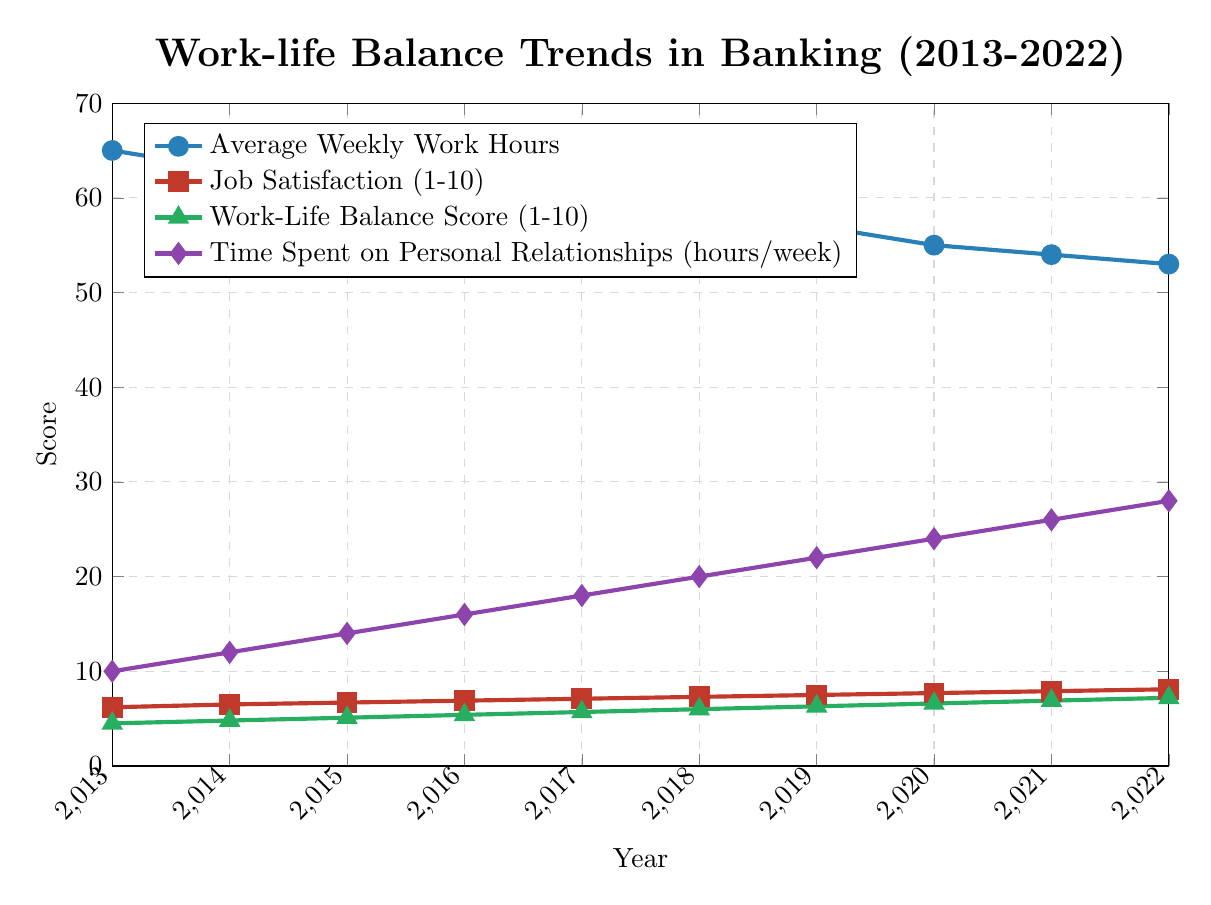How did the Average Weekly Work Hours change from 2013 to 2022? From the plot, the Average Weekly Work Hours decreased from 65 hours in 2013 to 53 hours in 2022.
Answer: Decreased from 65 to 53 hours Which year showed the highest Job Satisfaction score? Referring to the Job Satisfaction line (marked with squares), the highest value is in 2022 with a score of 8.1.
Answer: 2022 What is the trend in Time Spent on Personal Relationships from 2013 to 2022? The plot indicates a positive trend in Time Spent on Personal Relationships, increasing from 10 hours per week in 2013 to 28 hours per week in 2022.
Answer: Increasing By how much did the Work-Life Balance Score increase from 2013 to 2022? The Work-Life Balance Score increased from 4.5 in 2013 to 7.2 in 2022, resulting in an increase of 7.2 - 4.5 = 2.7.
Answer: 2.7 Which year experienced the lowest Stress Level and what was the score? The Stress Level line shows that 2022 had the lowest Stress Level with a score of 6.0.
Answer: 2022, 6.0 Compare the Job Satisfaction scores in 2015 and 2020. What is the difference? From the Job Satisfaction line, the score in 2015 was 6.7 and in 2020 it was 7.7. The difference is 7.7 - 6.7 = 1.0.
Answer: 1.0 What is the average Vacation Days Taken over the period 2013-2022? Summing the Vacation Days Taken over the 10 years: 12 + 13 + 14 + 15 + 16 + 17 + 18 + 19 + 20 + 21 = 165. The average is 165 / 10 = 16.5.
Answer: 16.5 In which year did the Time Spent on Personal Relationships exceed 20 hours per week for the first time? Referring to the plot, in 2019, the Time Spent on Personal Relationships first exceeded 20 hours per week, with a value of 22 hours.
Answer: 2019 How many more Vacation Days were taken in 2022 compared to 2013? In 2013, 12 Vacation Days were taken, and in 2022, 21 Vacation Days were taken. The increase is 21 - 12 = 9.
Answer: 9 